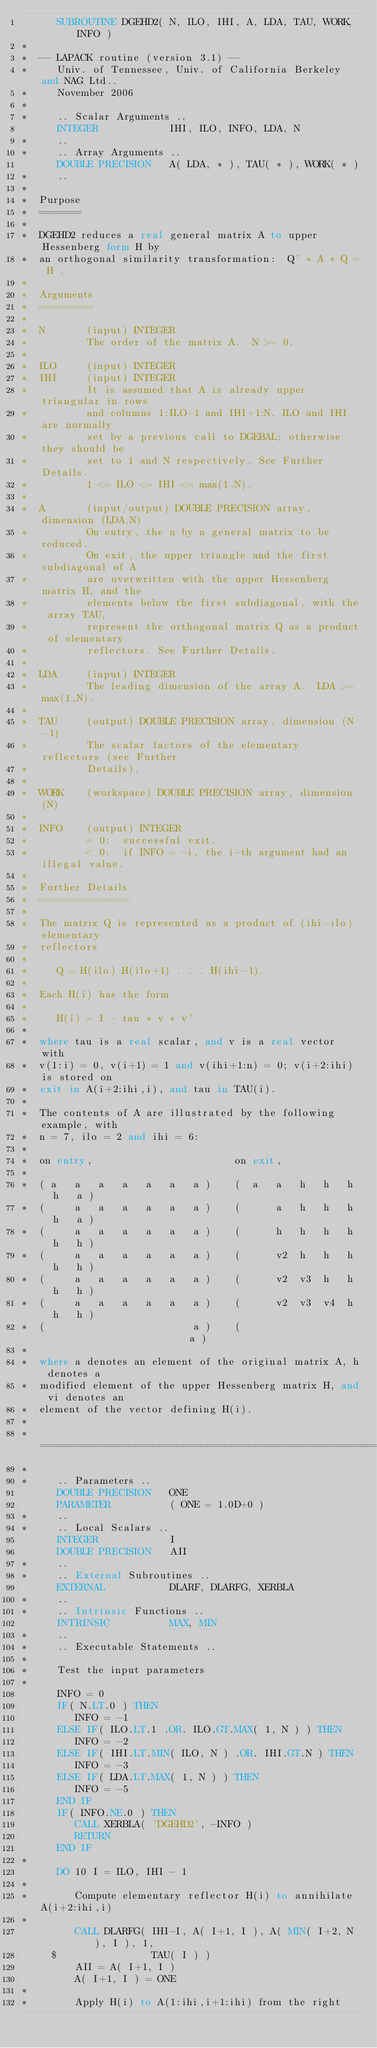Convert code to text. <code><loc_0><loc_0><loc_500><loc_500><_FORTRAN_>      SUBROUTINE DGEHD2( N, ILO, IHI, A, LDA, TAU, WORK, INFO )
*
*  -- LAPACK routine (version 3.1) --
*     Univ. of Tennessee, Univ. of California Berkeley and NAG Ltd..
*     November 2006
*
*     .. Scalar Arguments ..
      INTEGER            IHI, ILO, INFO, LDA, N
*     ..
*     .. Array Arguments ..
      DOUBLE PRECISION   A( LDA, * ), TAU( * ), WORK( * )
*     ..
*
*  Purpose
*  =======
*
*  DGEHD2 reduces a real general matrix A to upper Hessenberg form H by
*  an orthogonal similarity transformation:  Q' * A * Q = H .
*
*  Arguments
*  =========
*
*  N       (input) INTEGER
*          The order of the matrix A.  N >= 0.
*
*  ILO     (input) INTEGER
*  IHI     (input) INTEGER
*          It is assumed that A is already upper triangular in rows
*          and columns 1:ILO-1 and IHI+1:N. ILO and IHI are normally
*          set by a previous call to DGEBAL; otherwise they should be
*          set to 1 and N respectively. See Further Details.
*          1 <= ILO <= IHI <= max(1,N).
*
*  A       (input/output) DOUBLE PRECISION array, dimension (LDA,N)
*          On entry, the n by n general matrix to be reduced.
*          On exit, the upper triangle and the first subdiagonal of A
*          are overwritten with the upper Hessenberg matrix H, and the
*          elements below the first subdiagonal, with the array TAU,
*          represent the orthogonal matrix Q as a product of elementary
*          reflectors. See Further Details.
*
*  LDA     (input) INTEGER
*          The leading dimension of the array A.  LDA >= max(1,N).
*
*  TAU     (output) DOUBLE PRECISION array, dimension (N-1)
*          The scalar factors of the elementary reflectors (see Further
*          Details).
*
*  WORK    (workspace) DOUBLE PRECISION array, dimension (N)
*
*  INFO    (output) INTEGER
*          = 0:  successful exit.
*          < 0:  if INFO = -i, the i-th argument had an illegal value.
*
*  Further Details
*  ===============
*
*  The matrix Q is represented as a product of (ihi-ilo) elementary
*  reflectors
*
*     Q = H(ilo) H(ilo+1) . . . H(ihi-1).
*
*  Each H(i) has the form
*
*     H(i) = I - tau * v * v'
*
*  where tau is a real scalar, and v is a real vector with
*  v(1:i) = 0, v(i+1) = 1 and v(ihi+1:n) = 0; v(i+2:ihi) is stored on
*  exit in A(i+2:ihi,i), and tau in TAU(i).
*
*  The contents of A are illustrated by the following example, with
*  n = 7, ilo = 2 and ihi = 6:
*
*  on entry,                        on exit,
*
*  ( a   a   a   a   a   a   a )    (  a   a   h   h   h   h   a )
*  (     a   a   a   a   a   a )    (      a   h   h   h   h   a )
*  (     a   a   a   a   a   a )    (      h   h   h   h   h   h )
*  (     a   a   a   a   a   a )    (      v2  h   h   h   h   h )
*  (     a   a   a   a   a   a )    (      v2  v3  h   h   h   h )
*  (     a   a   a   a   a   a )    (      v2  v3  v4  h   h   h )
*  (                         a )    (                          a )
*
*  where a denotes an element of the original matrix A, h denotes a
*  modified element of the upper Hessenberg matrix H, and vi denotes an
*  element of the vector defining H(i).
*
*  =====================================================================
*
*     .. Parameters ..
      DOUBLE PRECISION   ONE
      PARAMETER          ( ONE = 1.0D+0 )
*     ..
*     .. Local Scalars ..
      INTEGER            I
      DOUBLE PRECISION   AII
*     ..
*     .. External Subroutines ..
      EXTERNAL           DLARF, DLARFG, XERBLA
*     ..
*     .. Intrinsic Functions ..
      INTRINSIC          MAX, MIN
*     ..
*     .. Executable Statements ..
*
*     Test the input parameters
*
      INFO = 0
      IF( N.LT.0 ) THEN
         INFO = -1
      ELSE IF( ILO.LT.1 .OR. ILO.GT.MAX( 1, N ) ) THEN
         INFO = -2
      ELSE IF( IHI.LT.MIN( ILO, N ) .OR. IHI.GT.N ) THEN
         INFO = -3
      ELSE IF( LDA.LT.MAX( 1, N ) ) THEN
         INFO = -5
      END IF
      IF( INFO.NE.0 ) THEN
         CALL XERBLA( 'DGEHD2', -INFO )
         RETURN
      END IF
*
      DO 10 I = ILO, IHI - 1
*
*        Compute elementary reflector H(i) to annihilate A(i+2:ihi,i)
*
         CALL DLARFG( IHI-I, A( I+1, I ), A( MIN( I+2, N ), I ), 1,
     $                TAU( I ) )
         AII = A( I+1, I )
         A( I+1, I ) = ONE
*
*        Apply H(i) to A(1:ihi,i+1:ihi) from the right</code> 